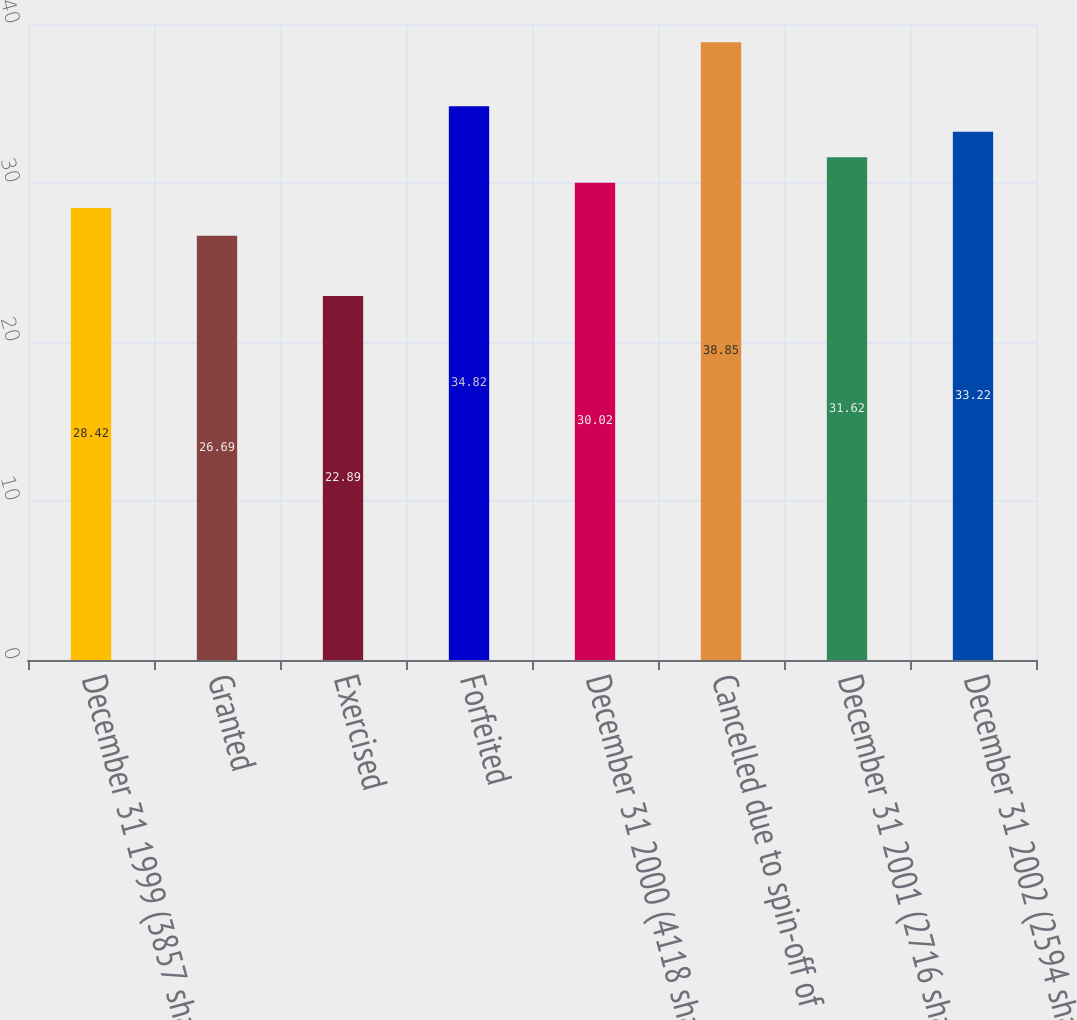<chart> <loc_0><loc_0><loc_500><loc_500><bar_chart><fcel>December 31 1999 (3857 shares<fcel>Granted<fcel>Exercised<fcel>Forfeited<fcel>December 31 2000 (4118 shares<fcel>Cancelled due to spin-off of<fcel>December 31 2001 (2716 shares<fcel>December 31 2002 (2594 shares<nl><fcel>28.42<fcel>26.69<fcel>22.89<fcel>34.82<fcel>30.02<fcel>38.85<fcel>31.62<fcel>33.22<nl></chart> 